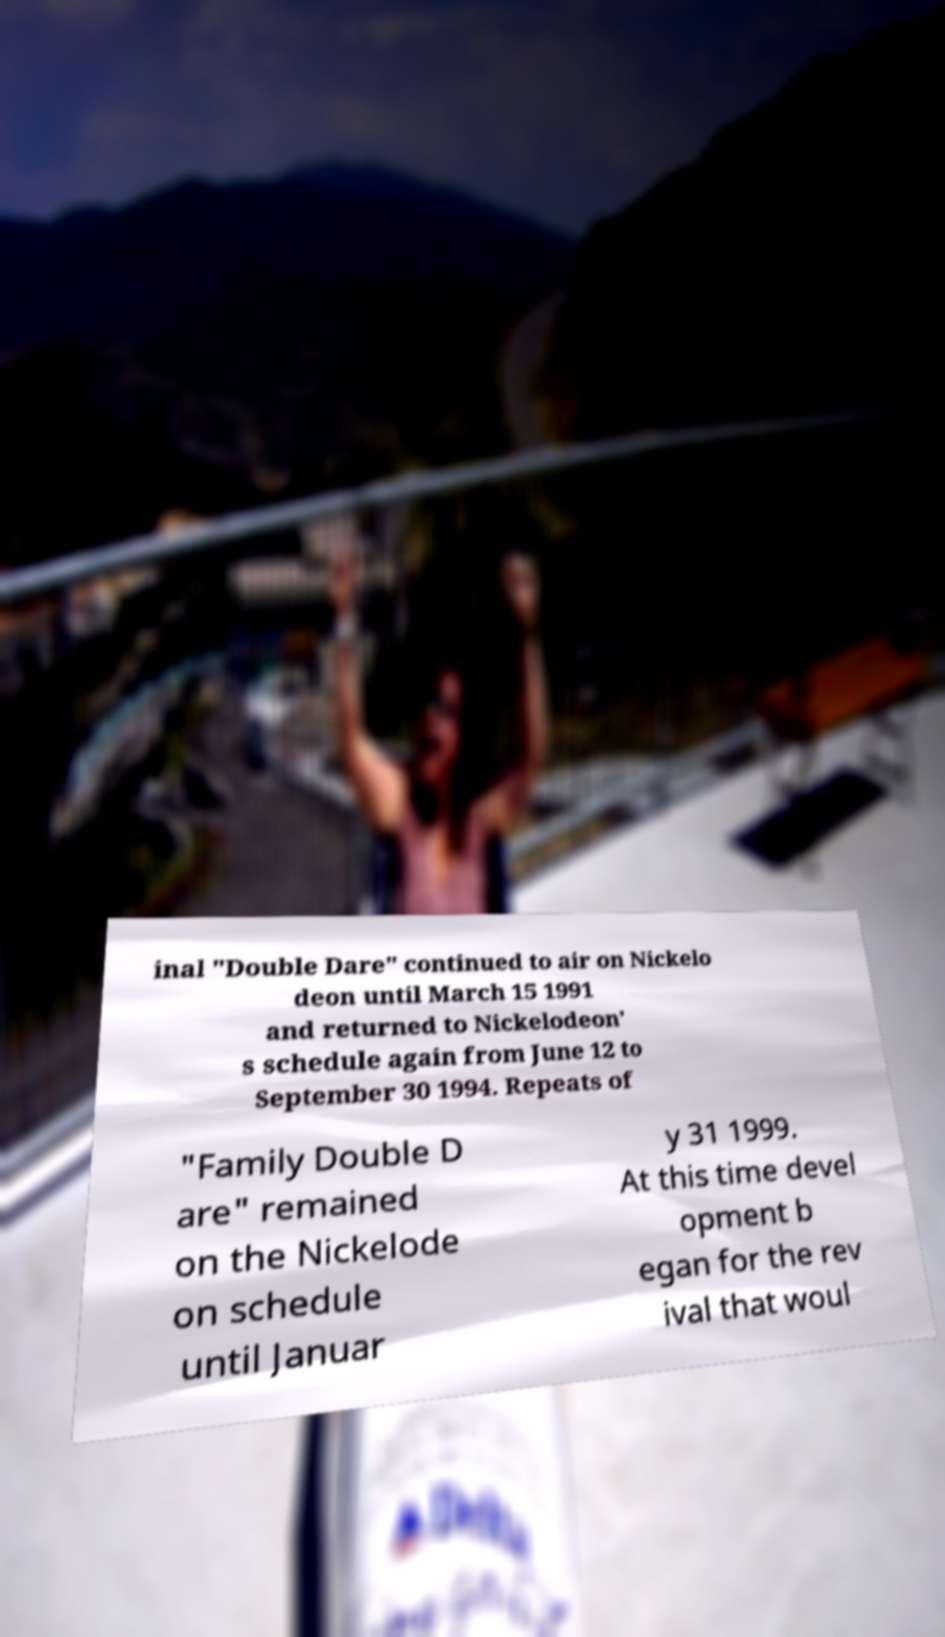What messages or text are displayed in this image? I need them in a readable, typed format. inal "Double Dare" continued to air on Nickelo deon until March 15 1991 and returned to Nickelodeon' s schedule again from June 12 to September 30 1994. Repeats of "Family Double D are" remained on the Nickelode on schedule until Januar y 31 1999. At this time devel opment b egan for the rev ival that woul 